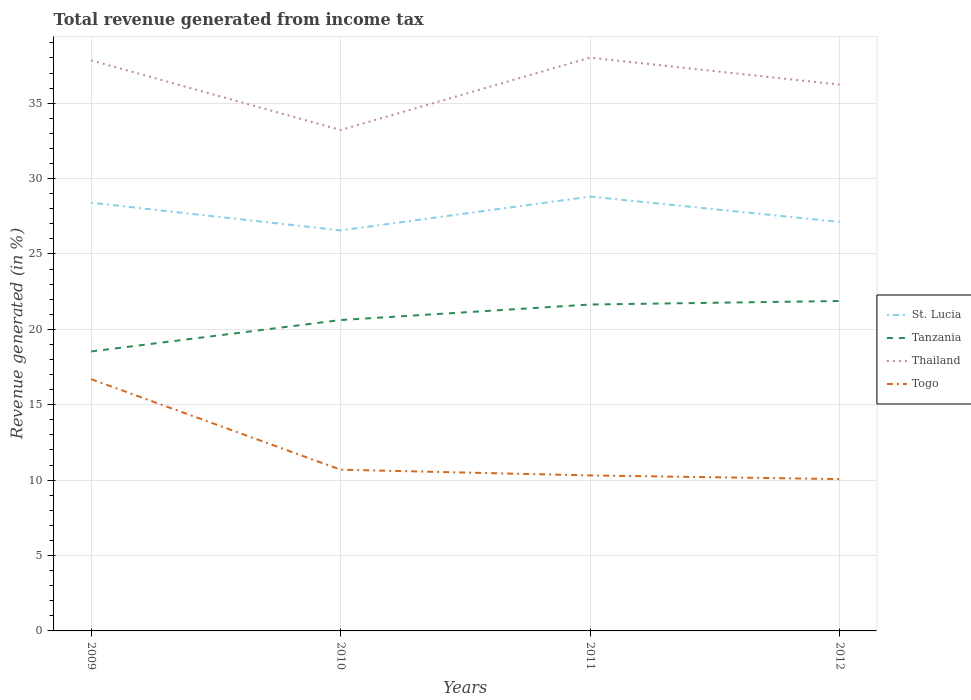Across all years, what is the maximum total revenue generated in Togo?
Offer a very short reply. 10.07. In which year was the total revenue generated in Tanzania maximum?
Your response must be concise. 2009. What is the total total revenue generated in St. Lucia in the graph?
Provide a succinct answer. -0.4. What is the difference between the highest and the second highest total revenue generated in Thailand?
Provide a succinct answer. 4.8. Is the total revenue generated in Togo strictly greater than the total revenue generated in St. Lucia over the years?
Provide a short and direct response. Yes. How many lines are there?
Offer a very short reply. 4. Are the values on the major ticks of Y-axis written in scientific E-notation?
Provide a succinct answer. No. Where does the legend appear in the graph?
Offer a very short reply. Center right. How are the legend labels stacked?
Your response must be concise. Vertical. What is the title of the graph?
Your response must be concise. Total revenue generated from income tax. What is the label or title of the Y-axis?
Your response must be concise. Revenue generated (in %). What is the Revenue generated (in %) in St. Lucia in 2009?
Provide a short and direct response. 28.4. What is the Revenue generated (in %) of Tanzania in 2009?
Provide a succinct answer. 18.53. What is the Revenue generated (in %) of Thailand in 2009?
Your answer should be compact. 37.84. What is the Revenue generated (in %) in Togo in 2009?
Offer a terse response. 16.7. What is the Revenue generated (in %) of St. Lucia in 2010?
Your response must be concise. 26.56. What is the Revenue generated (in %) in Tanzania in 2010?
Keep it short and to the point. 20.62. What is the Revenue generated (in %) in Thailand in 2010?
Your answer should be compact. 33.22. What is the Revenue generated (in %) in Togo in 2010?
Ensure brevity in your answer.  10.69. What is the Revenue generated (in %) of St. Lucia in 2011?
Your answer should be compact. 28.8. What is the Revenue generated (in %) of Tanzania in 2011?
Provide a succinct answer. 21.65. What is the Revenue generated (in %) of Thailand in 2011?
Offer a very short reply. 38.02. What is the Revenue generated (in %) in Togo in 2011?
Your response must be concise. 10.31. What is the Revenue generated (in %) in St. Lucia in 2012?
Offer a terse response. 27.13. What is the Revenue generated (in %) in Tanzania in 2012?
Your response must be concise. 21.88. What is the Revenue generated (in %) in Thailand in 2012?
Make the answer very short. 36.23. What is the Revenue generated (in %) of Togo in 2012?
Your response must be concise. 10.07. Across all years, what is the maximum Revenue generated (in %) of St. Lucia?
Offer a very short reply. 28.8. Across all years, what is the maximum Revenue generated (in %) in Tanzania?
Offer a very short reply. 21.88. Across all years, what is the maximum Revenue generated (in %) in Thailand?
Offer a terse response. 38.02. Across all years, what is the maximum Revenue generated (in %) in Togo?
Your answer should be compact. 16.7. Across all years, what is the minimum Revenue generated (in %) in St. Lucia?
Make the answer very short. 26.56. Across all years, what is the minimum Revenue generated (in %) in Tanzania?
Ensure brevity in your answer.  18.53. Across all years, what is the minimum Revenue generated (in %) in Thailand?
Provide a short and direct response. 33.22. Across all years, what is the minimum Revenue generated (in %) in Togo?
Ensure brevity in your answer.  10.07. What is the total Revenue generated (in %) of St. Lucia in the graph?
Provide a succinct answer. 110.89. What is the total Revenue generated (in %) of Tanzania in the graph?
Provide a succinct answer. 82.68. What is the total Revenue generated (in %) of Thailand in the graph?
Make the answer very short. 145.31. What is the total Revenue generated (in %) in Togo in the graph?
Offer a very short reply. 47.77. What is the difference between the Revenue generated (in %) of St. Lucia in 2009 and that in 2010?
Offer a very short reply. 1.84. What is the difference between the Revenue generated (in %) in Tanzania in 2009 and that in 2010?
Give a very brief answer. -2.08. What is the difference between the Revenue generated (in %) in Thailand in 2009 and that in 2010?
Ensure brevity in your answer.  4.62. What is the difference between the Revenue generated (in %) of Togo in 2009 and that in 2010?
Offer a terse response. 6. What is the difference between the Revenue generated (in %) of St. Lucia in 2009 and that in 2011?
Keep it short and to the point. -0.4. What is the difference between the Revenue generated (in %) in Tanzania in 2009 and that in 2011?
Your answer should be very brief. -3.11. What is the difference between the Revenue generated (in %) of Thailand in 2009 and that in 2011?
Your answer should be compact. -0.18. What is the difference between the Revenue generated (in %) of Togo in 2009 and that in 2011?
Your response must be concise. 6.38. What is the difference between the Revenue generated (in %) of St. Lucia in 2009 and that in 2012?
Give a very brief answer. 1.27. What is the difference between the Revenue generated (in %) of Tanzania in 2009 and that in 2012?
Ensure brevity in your answer.  -3.35. What is the difference between the Revenue generated (in %) of Thailand in 2009 and that in 2012?
Ensure brevity in your answer.  1.61. What is the difference between the Revenue generated (in %) in Togo in 2009 and that in 2012?
Provide a short and direct response. 6.63. What is the difference between the Revenue generated (in %) of St. Lucia in 2010 and that in 2011?
Your answer should be compact. -2.24. What is the difference between the Revenue generated (in %) in Tanzania in 2010 and that in 2011?
Your answer should be compact. -1.03. What is the difference between the Revenue generated (in %) of Thailand in 2010 and that in 2011?
Offer a very short reply. -4.8. What is the difference between the Revenue generated (in %) in Togo in 2010 and that in 2011?
Offer a very short reply. 0.38. What is the difference between the Revenue generated (in %) of St. Lucia in 2010 and that in 2012?
Offer a very short reply. -0.56. What is the difference between the Revenue generated (in %) in Tanzania in 2010 and that in 2012?
Ensure brevity in your answer.  -1.26. What is the difference between the Revenue generated (in %) of Thailand in 2010 and that in 2012?
Offer a terse response. -3.01. What is the difference between the Revenue generated (in %) in Togo in 2010 and that in 2012?
Keep it short and to the point. 0.62. What is the difference between the Revenue generated (in %) in St. Lucia in 2011 and that in 2012?
Keep it short and to the point. 1.68. What is the difference between the Revenue generated (in %) in Tanzania in 2011 and that in 2012?
Your answer should be compact. -0.23. What is the difference between the Revenue generated (in %) of Thailand in 2011 and that in 2012?
Offer a very short reply. 1.79. What is the difference between the Revenue generated (in %) in Togo in 2011 and that in 2012?
Provide a succinct answer. 0.24. What is the difference between the Revenue generated (in %) in St. Lucia in 2009 and the Revenue generated (in %) in Tanzania in 2010?
Your response must be concise. 7.78. What is the difference between the Revenue generated (in %) in St. Lucia in 2009 and the Revenue generated (in %) in Thailand in 2010?
Your answer should be very brief. -4.82. What is the difference between the Revenue generated (in %) of St. Lucia in 2009 and the Revenue generated (in %) of Togo in 2010?
Ensure brevity in your answer.  17.71. What is the difference between the Revenue generated (in %) of Tanzania in 2009 and the Revenue generated (in %) of Thailand in 2010?
Make the answer very short. -14.69. What is the difference between the Revenue generated (in %) of Tanzania in 2009 and the Revenue generated (in %) of Togo in 2010?
Your answer should be very brief. 7.84. What is the difference between the Revenue generated (in %) in Thailand in 2009 and the Revenue generated (in %) in Togo in 2010?
Your answer should be very brief. 27.15. What is the difference between the Revenue generated (in %) of St. Lucia in 2009 and the Revenue generated (in %) of Tanzania in 2011?
Offer a terse response. 6.75. What is the difference between the Revenue generated (in %) in St. Lucia in 2009 and the Revenue generated (in %) in Thailand in 2011?
Keep it short and to the point. -9.62. What is the difference between the Revenue generated (in %) of St. Lucia in 2009 and the Revenue generated (in %) of Togo in 2011?
Offer a very short reply. 18.09. What is the difference between the Revenue generated (in %) of Tanzania in 2009 and the Revenue generated (in %) of Thailand in 2011?
Keep it short and to the point. -19.49. What is the difference between the Revenue generated (in %) in Tanzania in 2009 and the Revenue generated (in %) in Togo in 2011?
Give a very brief answer. 8.22. What is the difference between the Revenue generated (in %) in Thailand in 2009 and the Revenue generated (in %) in Togo in 2011?
Your answer should be compact. 27.53. What is the difference between the Revenue generated (in %) of St. Lucia in 2009 and the Revenue generated (in %) of Tanzania in 2012?
Offer a very short reply. 6.52. What is the difference between the Revenue generated (in %) in St. Lucia in 2009 and the Revenue generated (in %) in Thailand in 2012?
Provide a short and direct response. -7.83. What is the difference between the Revenue generated (in %) of St. Lucia in 2009 and the Revenue generated (in %) of Togo in 2012?
Ensure brevity in your answer.  18.33. What is the difference between the Revenue generated (in %) in Tanzania in 2009 and the Revenue generated (in %) in Thailand in 2012?
Give a very brief answer. -17.7. What is the difference between the Revenue generated (in %) in Tanzania in 2009 and the Revenue generated (in %) in Togo in 2012?
Your answer should be compact. 8.46. What is the difference between the Revenue generated (in %) in Thailand in 2009 and the Revenue generated (in %) in Togo in 2012?
Provide a short and direct response. 27.77. What is the difference between the Revenue generated (in %) of St. Lucia in 2010 and the Revenue generated (in %) of Tanzania in 2011?
Offer a very short reply. 4.92. What is the difference between the Revenue generated (in %) of St. Lucia in 2010 and the Revenue generated (in %) of Thailand in 2011?
Your answer should be compact. -11.46. What is the difference between the Revenue generated (in %) in St. Lucia in 2010 and the Revenue generated (in %) in Togo in 2011?
Your answer should be very brief. 16.25. What is the difference between the Revenue generated (in %) of Tanzania in 2010 and the Revenue generated (in %) of Thailand in 2011?
Offer a terse response. -17.4. What is the difference between the Revenue generated (in %) in Tanzania in 2010 and the Revenue generated (in %) in Togo in 2011?
Offer a terse response. 10.3. What is the difference between the Revenue generated (in %) in Thailand in 2010 and the Revenue generated (in %) in Togo in 2011?
Offer a very short reply. 22.91. What is the difference between the Revenue generated (in %) of St. Lucia in 2010 and the Revenue generated (in %) of Tanzania in 2012?
Your answer should be very brief. 4.68. What is the difference between the Revenue generated (in %) of St. Lucia in 2010 and the Revenue generated (in %) of Thailand in 2012?
Provide a succinct answer. -9.67. What is the difference between the Revenue generated (in %) of St. Lucia in 2010 and the Revenue generated (in %) of Togo in 2012?
Give a very brief answer. 16.49. What is the difference between the Revenue generated (in %) in Tanzania in 2010 and the Revenue generated (in %) in Thailand in 2012?
Provide a short and direct response. -15.61. What is the difference between the Revenue generated (in %) in Tanzania in 2010 and the Revenue generated (in %) in Togo in 2012?
Provide a succinct answer. 10.55. What is the difference between the Revenue generated (in %) of Thailand in 2010 and the Revenue generated (in %) of Togo in 2012?
Provide a succinct answer. 23.15. What is the difference between the Revenue generated (in %) in St. Lucia in 2011 and the Revenue generated (in %) in Tanzania in 2012?
Keep it short and to the point. 6.92. What is the difference between the Revenue generated (in %) of St. Lucia in 2011 and the Revenue generated (in %) of Thailand in 2012?
Give a very brief answer. -7.43. What is the difference between the Revenue generated (in %) of St. Lucia in 2011 and the Revenue generated (in %) of Togo in 2012?
Your response must be concise. 18.73. What is the difference between the Revenue generated (in %) in Tanzania in 2011 and the Revenue generated (in %) in Thailand in 2012?
Offer a terse response. -14.58. What is the difference between the Revenue generated (in %) in Tanzania in 2011 and the Revenue generated (in %) in Togo in 2012?
Provide a succinct answer. 11.58. What is the difference between the Revenue generated (in %) in Thailand in 2011 and the Revenue generated (in %) in Togo in 2012?
Offer a very short reply. 27.95. What is the average Revenue generated (in %) of St. Lucia per year?
Offer a very short reply. 27.72. What is the average Revenue generated (in %) in Tanzania per year?
Your answer should be compact. 20.67. What is the average Revenue generated (in %) in Thailand per year?
Keep it short and to the point. 36.33. What is the average Revenue generated (in %) in Togo per year?
Offer a terse response. 11.94. In the year 2009, what is the difference between the Revenue generated (in %) of St. Lucia and Revenue generated (in %) of Tanzania?
Make the answer very short. 9.87. In the year 2009, what is the difference between the Revenue generated (in %) in St. Lucia and Revenue generated (in %) in Thailand?
Your answer should be compact. -9.44. In the year 2009, what is the difference between the Revenue generated (in %) of St. Lucia and Revenue generated (in %) of Togo?
Ensure brevity in your answer.  11.7. In the year 2009, what is the difference between the Revenue generated (in %) of Tanzania and Revenue generated (in %) of Thailand?
Your answer should be compact. -19.3. In the year 2009, what is the difference between the Revenue generated (in %) of Tanzania and Revenue generated (in %) of Togo?
Your answer should be compact. 1.84. In the year 2009, what is the difference between the Revenue generated (in %) in Thailand and Revenue generated (in %) in Togo?
Keep it short and to the point. 21.14. In the year 2010, what is the difference between the Revenue generated (in %) of St. Lucia and Revenue generated (in %) of Tanzania?
Offer a very short reply. 5.95. In the year 2010, what is the difference between the Revenue generated (in %) of St. Lucia and Revenue generated (in %) of Thailand?
Give a very brief answer. -6.66. In the year 2010, what is the difference between the Revenue generated (in %) of St. Lucia and Revenue generated (in %) of Togo?
Your answer should be very brief. 15.87. In the year 2010, what is the difference between the Revenue generated (in %) in Tanzania and Revenue generated (in %) in Thailand?
Provide a short and direct response. -12.61. In the year 2010, what is the difference between the Revenue generated (in %) in Tanzania and Revenue generated (in %) in Togo?
Your answer should be very brief. 9.92. In the year 2010, what is the difference between the Revenue generated (in %) in Thailand and Revenue generated (in %) in Togo?
Your answer should be very brief. 22.53. In the year 2011, what is the difference between the Revenue generated (in %) of St. Lucia and Revenue generated (in %) of Tanzania?
Provide a succinct answer. 7.16. In the year 2011, what is the difference between the Revenue generated (in %) of St. Lucia and Revenue generated (in %) of Thailand?
Ensure brevity in your answer.  -9.22. In the year 2011, what is the difference between the Revenue generated (in %) in St. Lucia and Revenue generated (in %) in Togo?
Offer a terse response. 18.49. In the year 2011, what is the difference between the Revenue generated (in %) of Tanzania and Revenue generated (in %) of Thailand?
Your answer should be very brief. -16.37. In the year 2011, what is the difference between the Revenue generated (in %) of Tanzania and Revenue generated (in %) of Togo?
Ensure brevity in your answer.  11.33. In the year 2011, what is the difference between the Revenue generated (in %) of Thailand and Revenue generated (in %) of Togo?
Offer a terse response. 27.71. In the year 2012, what is the difference between the Revenue generated (in %) of St. Lucia and Revenue generated (in %) of Tanzania?
Offer a terse response. 5.25. In the year 2012, what is the difference between the Revenue generated (in %) in St. Lucia and Revenue generated (in %) in Thailand?
Offer a terse response. -9.1. In the year 2012, what is the difference between the Revenue generated (in %) of St. Lucia and Revenue generated (in %) of Togo?
Make the answer very short. 17.06. In the year 2012, what is the difference between the Revenue generated (in %) in Tanzania and Revenue generated (in %) in Thailand?
Offer a terse response. -14.35. In the year 2012, what is the difference between the Revenue generated (in %) in Tanzania and Revenue generated (in %) in Togo?
Provide a succinct answer. 11.81. In the year 2012, what is the difference between the Revenue generated (in %) in Thailand and Revenue generated (in %) in Togo?
Your answer should be compact. 26.16. What is the ratio of the Revenue generated (in %) in St. Lucia in 2009 to that in 2010?
Ensure brevity in your answer.  1.07. What is the ratio of the Revenue generated (in %) in Tanzania in 2009 to that in 2010?
Offer a terse response. 0.9. What is the ratio of the Revenue generated (in %) in Thailand in 2009 to that in 2010?
Provide a short and direct response. 1.14. What is the ratio of the Revenue generated (in %) of Togo in 2009 to that in 2010?
Provide a short and direct response. 1.56. What is the ratio of the Revenue generated (in %) of St. Lucia in 2009 to that in 2011?
Your response must be concise. 0.99. What is the ratio of the Revenue generated (in %) of Tanzania in 2009 to that in 2011?
Your answer should be compact. 0.86. What is the ratio of the Revenue generated (in %) of Thailand in 2009 to that in 2011?
Your answer should be very brief. 1. What is the ratio of the Revenue generated (in %) in Togo in 2009 to that in 2011?
Ensure brevity in your answer.  1.62. What is the ratio of the Revenue generated (in %) of St. Lucia in 2009 to that in 2012?
Offer a terse response. 1.05. What is the ratio of the Revenue generated (in %) in Tanzania in 2009 to that in 2012?
Offer a very short reply. 0.85. What is the ratio of the Revenue generated (in %) of Thailand in 2009 to that in 2012?
Offer a terse response. 1.04. What is the ratio of the Revenue generated (in %) of Togo in 2009 to that in 2012?
Provide a short and direct response. 1.66. What is the ratio of the Revenue generated (in %) of St. Lucia in 2010 to that in 2011?
Your answer should be compact. 0.92. What is the ratio of the Revenue generated (in %) in Tanzania in 2010 to that in 2011?
Your response must be concise. 0.95. What is the ratio of the Revenue generated (in %) of Thailand in 2010 to that in 2011?
Give a very brief answer. 0.87. What is the ratio of the Revenue generated (in %) of Togo in 2010 to that in 2011?
Make the answer very short. 1.04. What is the ratio of the Revenue generated (in %) of St. Lucia in 2010 to that in 2012?
Offer a terse response. 0.98. What is the ratio of the Revenue generated (in %) in Tanzania in 2010 to that in 2012?
Your response must be concise. 0.94. What is the ratio of the Revenue generated (in %) in Thailand in 2010 to that in 2012?
Your answer should be very brief. 0.92. What is the ratio of the Revenue generated (in %) in Togo in 2010 to that in 2012?
Your answer should be very brief. 1.06. What is the ratio of the Revenue generated (in %) in St. Lucia in 2011 to that in 2012?
Offer a very short reply. 1.06. What is the ratio of the Revenue generated (in %) in Tanzania in 2011 to that in 2012?
Ensure brevity in your answer.  0.99. What is the ratio of the Revenue generated (in %) in Thailand in 2011 to that in 2012?
Your response must be concise. 1.05. What is the ratio of the Revenue generated (in %) in Togo in 2011 to that in 2012?
Give a very brief answer. 1.02. What is the difference between the highest and the second highest Revenue generated (in %) in St. Lucia?
Provide a short and direct response. 0.4. What is the difference between the highest and the second highest Revenue generated (in %) of Tanzania?
Ensure brevity in your answer.  0.23. What is the difference between the highest and the second highest Revenue generated (in %) of Thailand?
Your answer should be very brief. 0.18. What is the difference between the highest and the second highest Revenue generated (in %) of Togo?
Ensure brevity in your answer.  6. What is the difference between the highest and the lowest Revenue generated (in %) of St. Lucia?
Provide a succinct answer. 2.24. What is the difference between the highest and the lowest Revenue generated (in %) in Tanzania?
Your answer should be very brief. 3.35. What is the difference between the highest and the lowest Revenue generated (in %) of Thailand?
Your answer should be compact. 4.8. What is the difference between the highest and the lowest Revenue generated (in %) of Togo?
Provide a succinct answer. 6.63. 